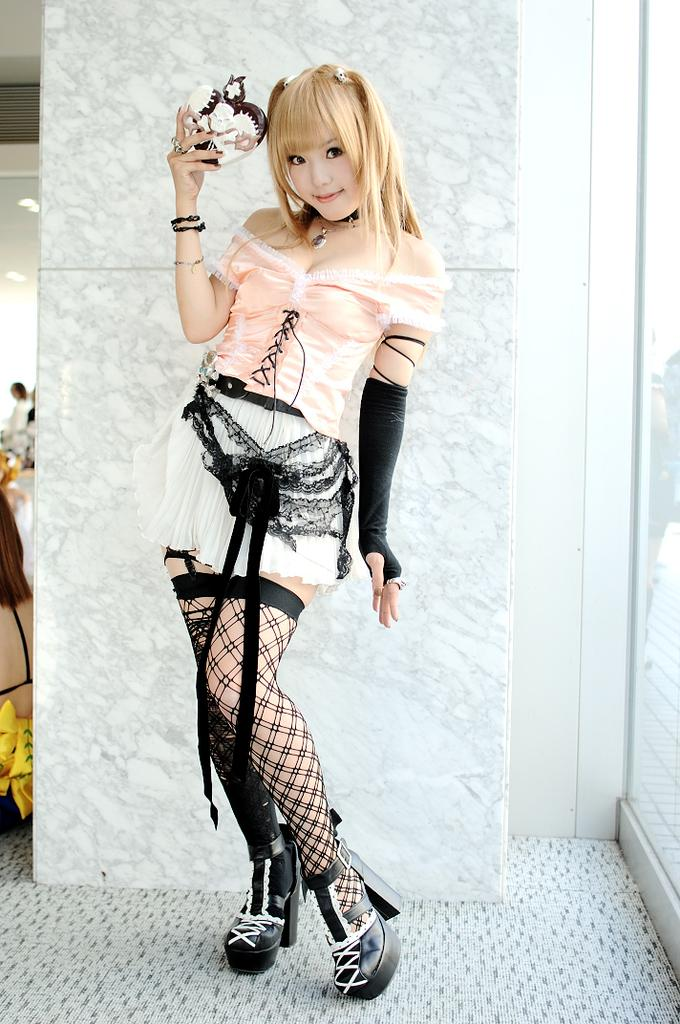Who or what is present in the image? There is a person in the image. What can be observed about the person's attire? The person is wearing clothes. What is the background of the image? The person is standing in front of a wall. What is the person holding in her hand? The person is holding an object in her hand. What type of head can be seen on the rabbit in the image? There is no rabbit present in the image. 